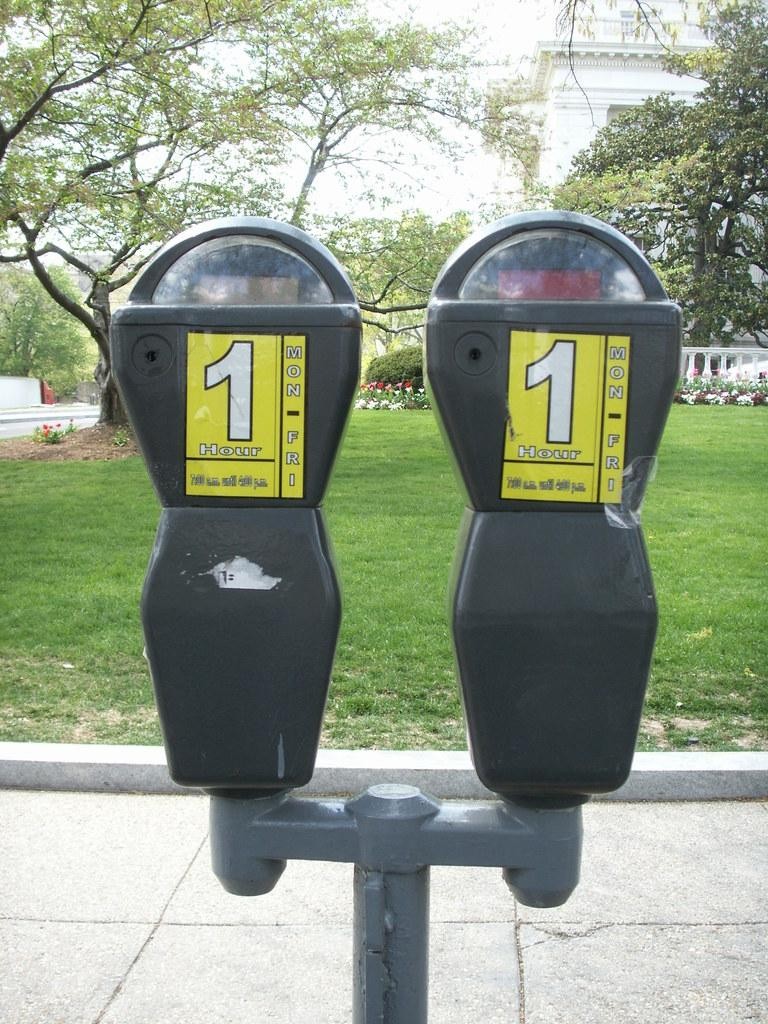<image>
Give a short and clear explanation of the subsequent image. 2 parking meters side by side that say 1 hour on them. 